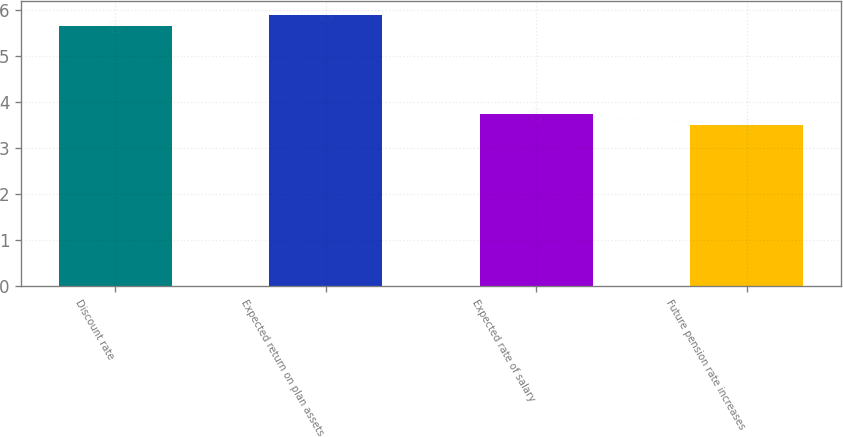Convert chart. <chart><loc_0><loc_0><loc_500><loc_500><bar_chart><fcel>Discount rate<fcel>Expected return on plan assets<fcel>Expected rate of salary<fcel>Future pension rate increases<nl><fcel>5.65<fcel>5.89<fcel>3.73<fcel>3.49<nl></chart> 